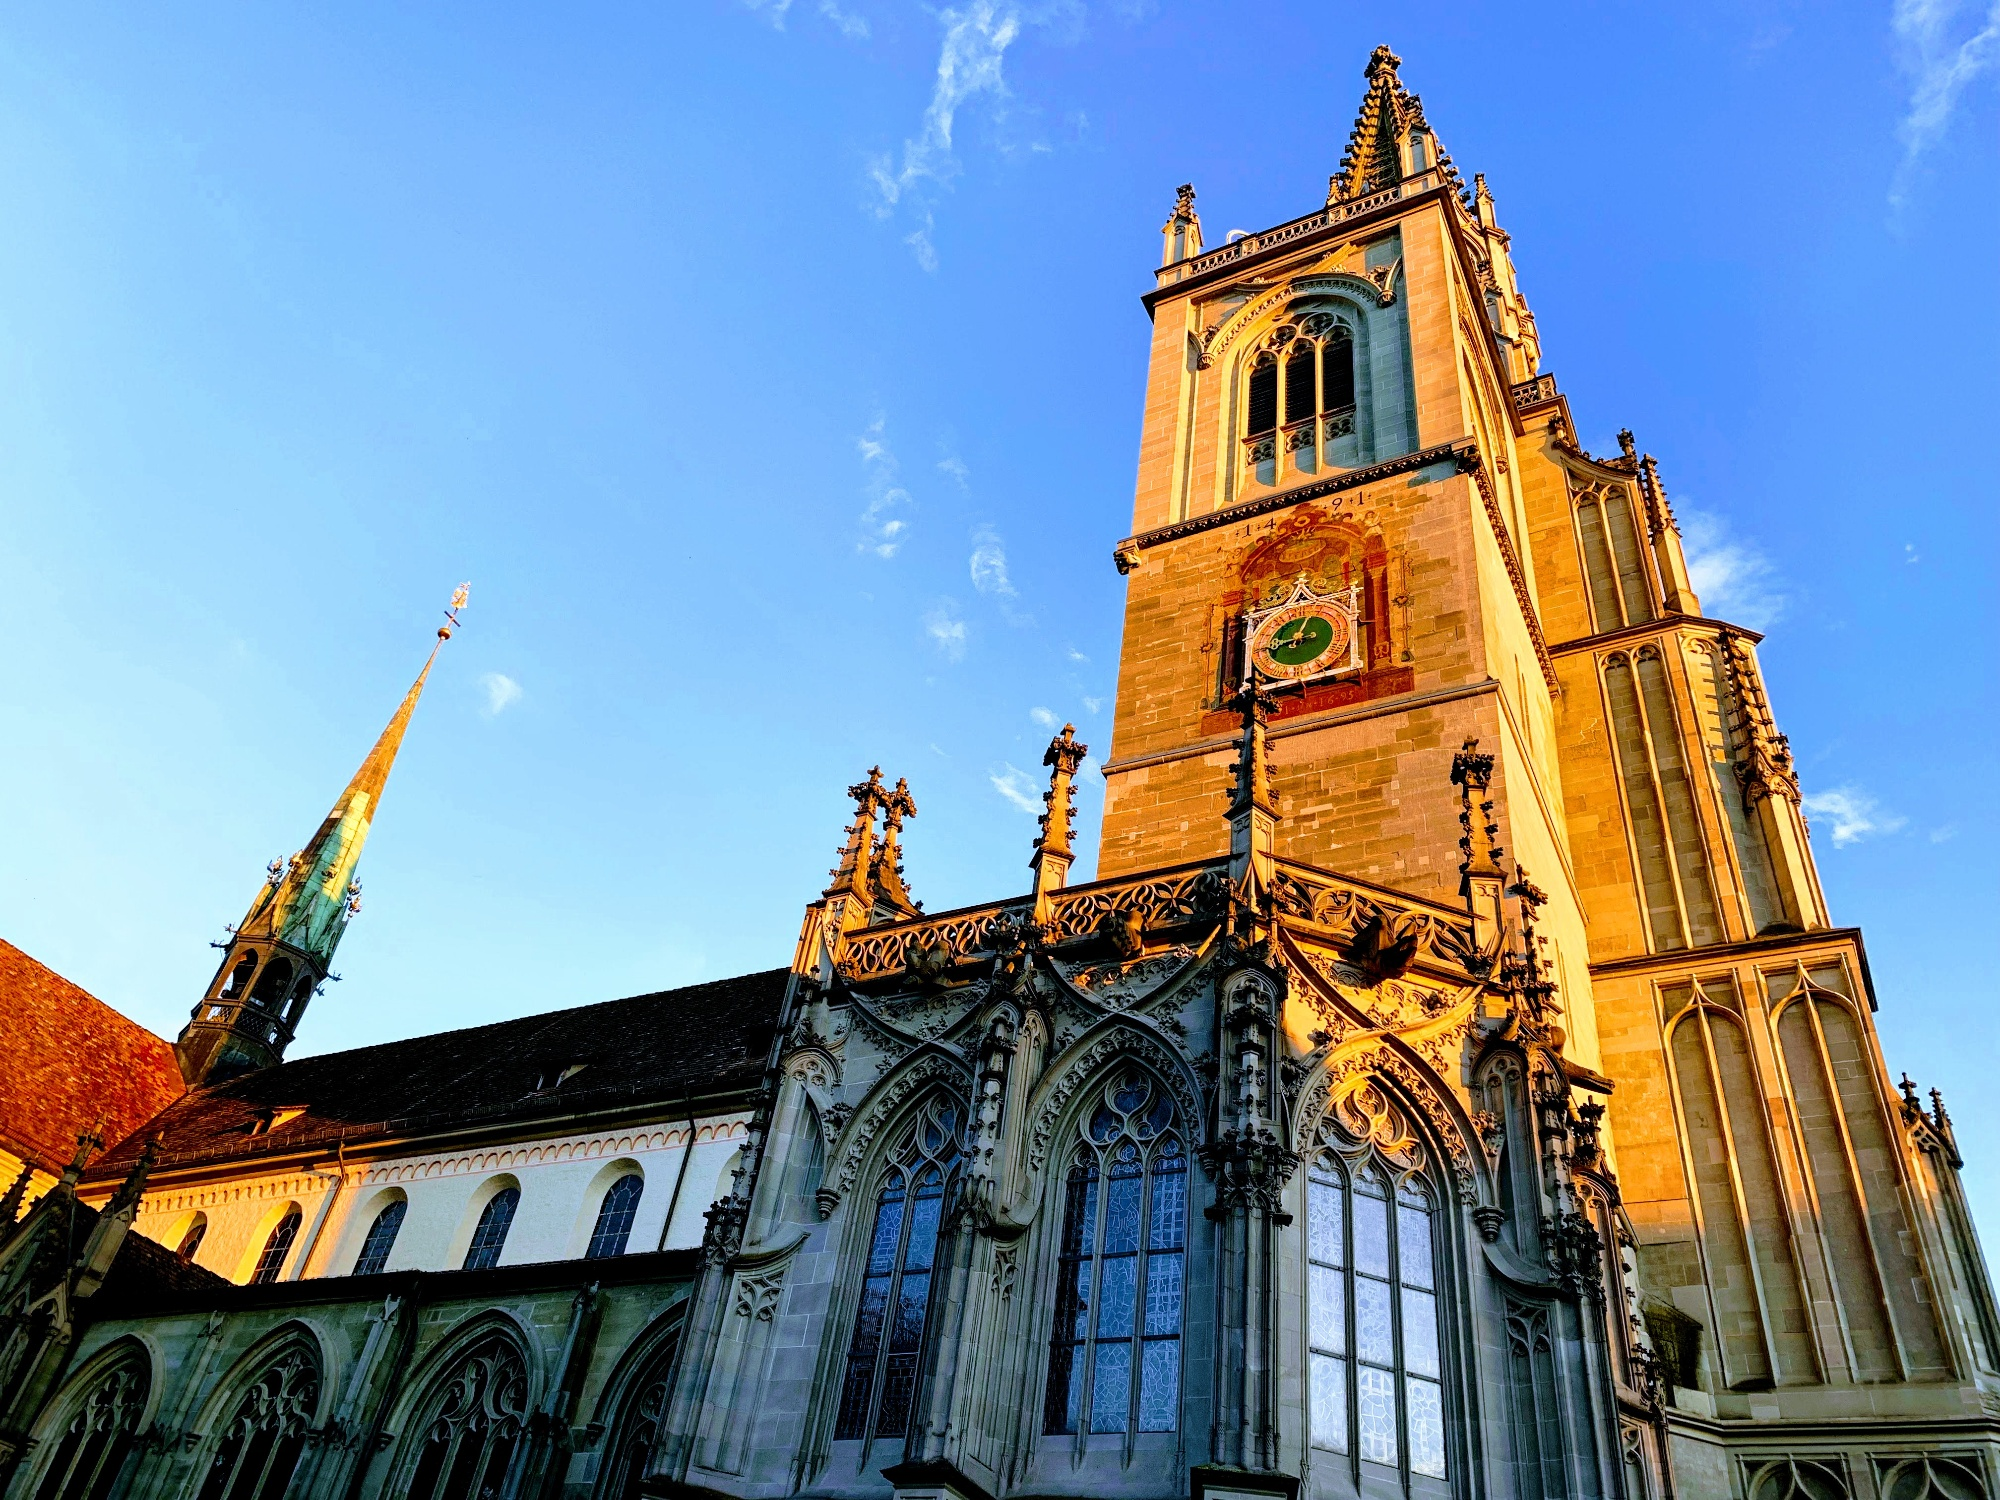How does the architecture of Konstanz Minster reflect its historical significance? The architecture of Konstanz Minster is a testament to its historical and cultural significance. The Gothic design reflects the artistic and architectural trends of the medieval period when the cathedral was most influential. The towering spires, intricate stone carvings, and expansive stained glass windows are characteristic of Gothic architecture, symbolizing the church’s reach towards the heavens and its role as a beacon of faith. The detailed facades and buttresses are not only aesthetically stunning but also demonstrate the advanced engineering and craftsmanship of the time. Inside, the vaulted ceilings and grand altars underscore the cathedral's importance in religious ceremonies and its pivotal role during the Council of Constance. Thus, every element of Konstanz Minster's architecture tells a story of its rich history and enduring legacy. 